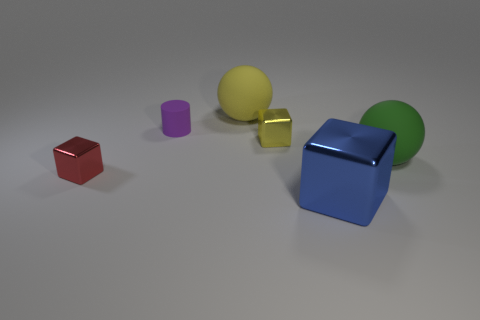Subtract all gray cylinders. Subtract all red balls. How many cylinders are left? 1 Add 4 shiny cubes. How many objects exist? 10 Subtract all cylinders. How many objects are left? 5 Add 6 matte things. How many matte things are left? 9 Add 6 cyan matte cubes. How many cyan matte cubes exist? 6 Subtract 0 blue cylinders. How many objects are left? 6 Subtract all small purple metal things. Subtract all small shiny things. How many objects are left? 4 